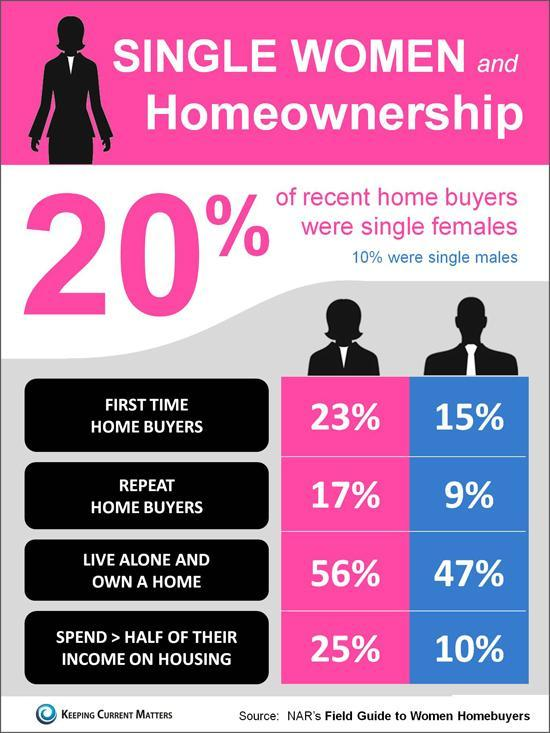how many females live alone and own a home
Answer the question with a short phrase. 56% How much higher in % are home buyers single females than single males 10 how many % males are repeat home buyers 9% In which gender do 25% spend > half of their income on housing female 